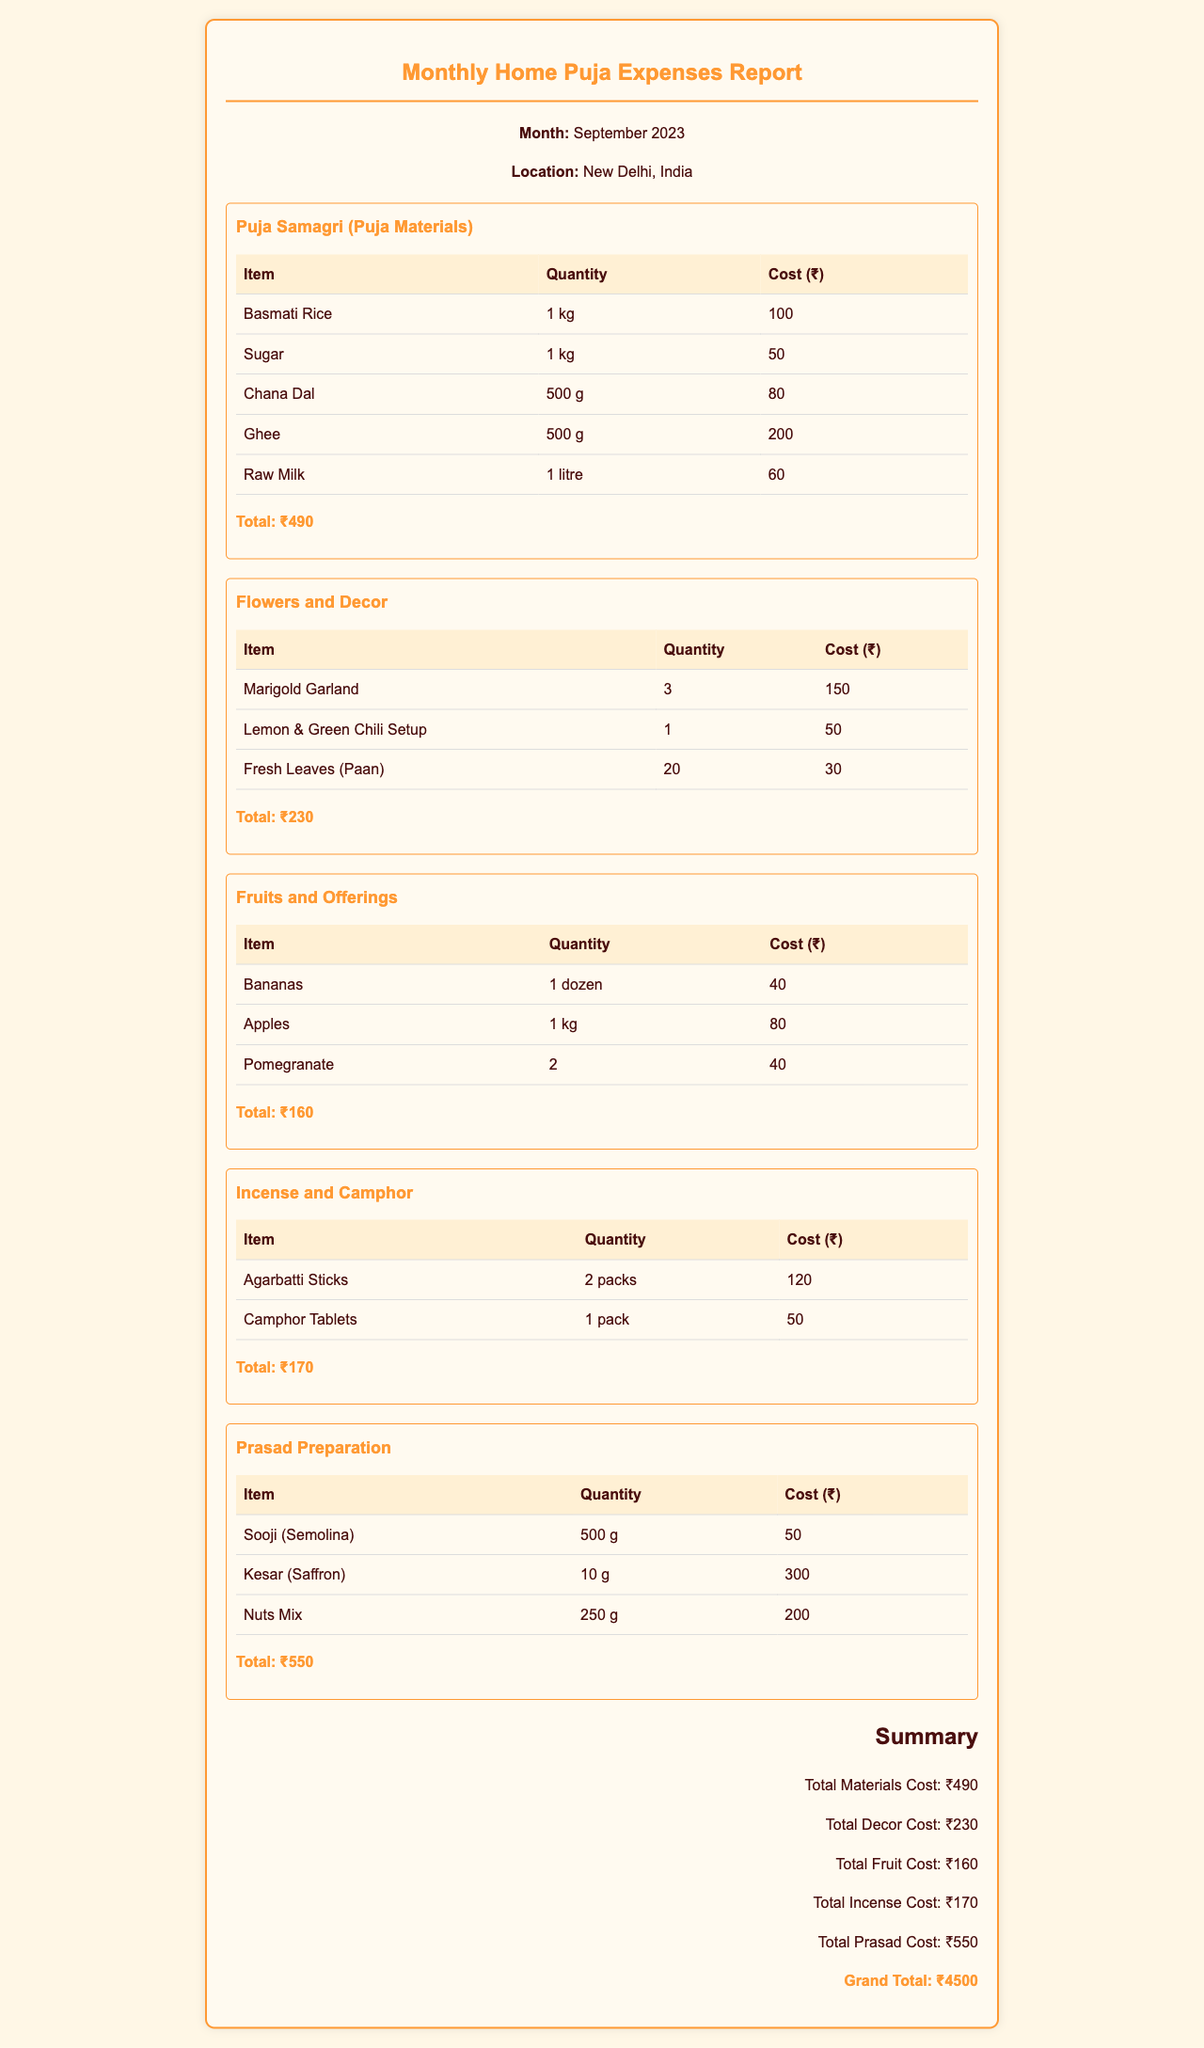What is the total cost for Puja Samagri? The total cost for Puja Samagri is listed in the document under the respective category, which is ₹490.
Answer: ₹490 How many Marigold Garlands were purchased? The quantity of Marigold Garlands is specified in the "Flowers and Decor" section, which states 3 were purchased.
Answer: 3 What is the cost of Kesar (Saffron)? The cost of Kesar (Saffron) is given in the "Prasad Preparation" category, which is ₹300.
Answer: ₹300 What is the grand total of all expenses? The grand total is provided in the summary section at the end of the document, which sums up to ₹4500.
Answer: ₹4500 How many types of offerings are listed in the Fruits and Offerings section? The document lists three types of offerings in the "Fruits and Offerings" section.
Answer: 3 What is the quantity of Agarabatti Sticks purchased? The document specifies that 2 packs of Agarabatti Sticks were purchased in the "Incense and Camphor" section.
Answer: 2 packs What is the total cost of flowers and decor? The total cost for flowers and decor is mentioned in the document as ₹230.
Answer: ₹230 Which item had the highest cost in the Prasad Preparation? The highest cost item in the "Prasad Preparation" category is Kesar (Saffron), which costs ₹300.
Answer: Kesar (Saffron) How much did the Fresh Leaves (Paan) cost? The cost of Fresh Leaves (Paan) is specified in the "Flowers and Decor" section, which is ₹30.
Answer: ₹30 